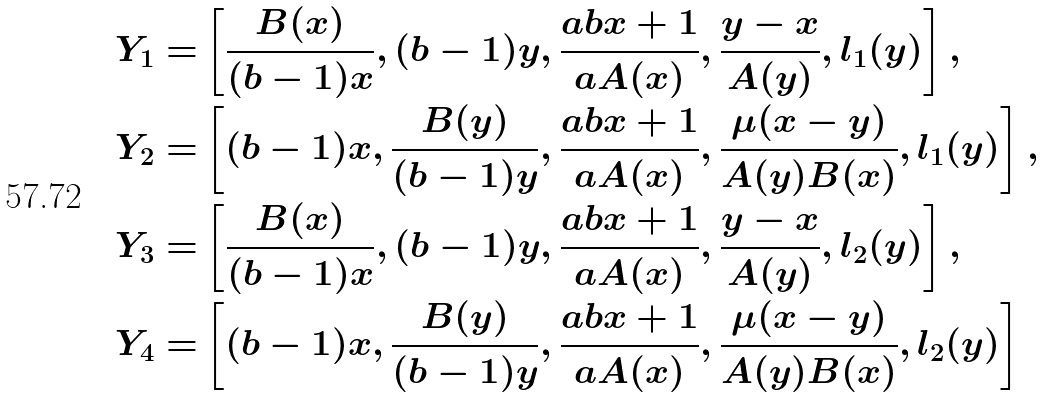<formula> <loc_0><loc_0><loc_500><loc_500>Y _ { 1 } = & \left [ \frac { B ( x ) } { ( b - 1 ) x } , ( b - 1 ) y , \frac { a b x + 1 } { a A ( x ) } , \frac { y - x } { A ( y ) } , l _ { 1 } ( y ) \right ] , \\ Y _ { 2 } = & \left [ ( b - 1 ) x , \frac { B ( y ) } { ( b - 1 ) y } , \frac { a b x + 1 } { a A ( x ) } , \frac { \mu ( x - y ) } { A ( y ) B ( x ) } , l _ { 1 } ( y ) \right ] , \\ Y _ { 3 } = & \left [ \frac { B ( x ) } { ( b - 1 ) x } , ( b - 1 ) y , \frac { a b x + 1 } { a A ( x ) } , \frac { y - x } { A ( y ) } , l _ { 2 } ( y ) \right ] , \\ Y _ { 4 } = & \left [ ( b - 1 ) x , \frac { B ( y ) } { ( b - 1 ) y } , \frac { a b x + 1 } { a A ( x ) } , \frac { \mu ( x - y ) } { A ( y ) B ( x ) } , l _ { 2 } ( y ) \right ]</formula> 